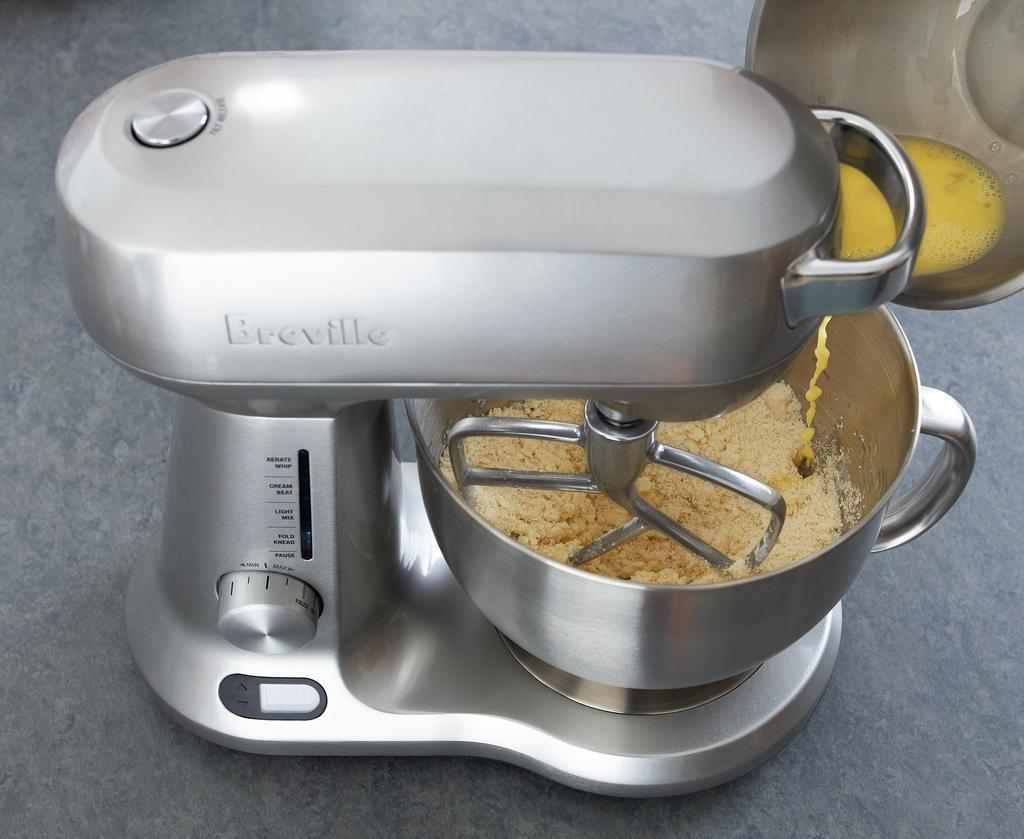<image>
Create a compact narrative representing the image presented. A Breville brand stand mixer is working on a batch of dough. 